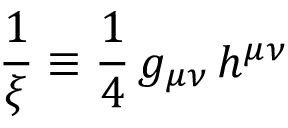<formula> <loc_0><loc_0><loc_500><loc_500>\frac { 1 } { \xi } \equiv \frac { 1 } { 4 } \, g _ { \mu \nu } \, h ^ { \mu \nu }</formula> 